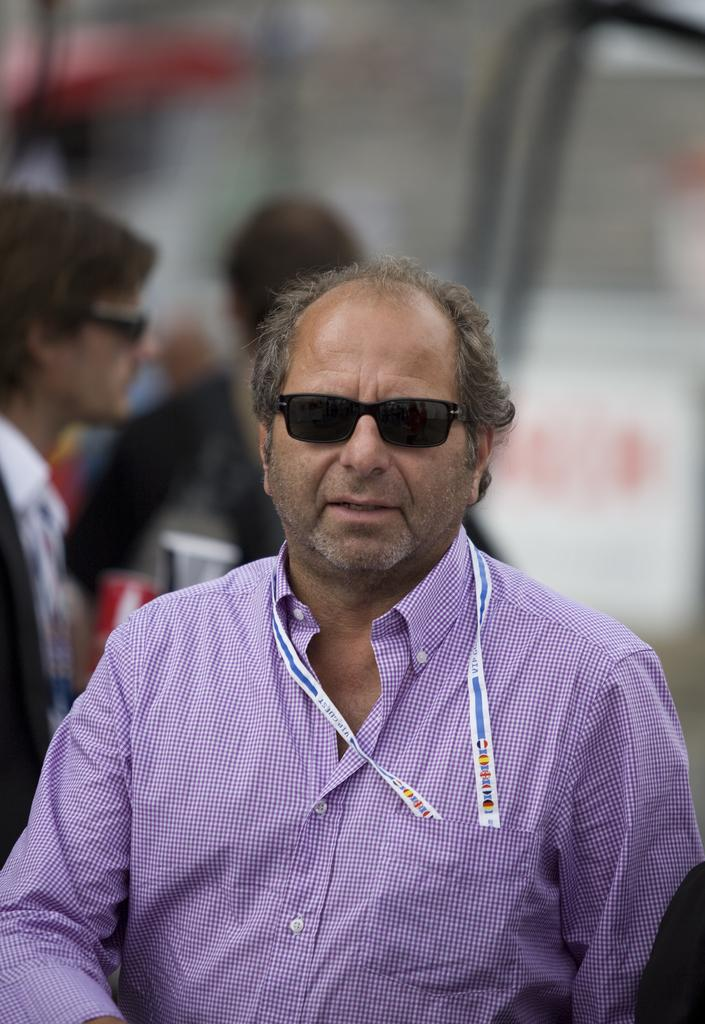Who is the main subject in the image? There is a man in the image. What is the man wearing on his upper body? The man is wearing a blue shirt. What type of eyewear is the man wearing? The man is wearing black shades. Can you describe the background of the image? There are many people in the background of the image, and the background is blurred. What type of quiver is the man carrying in the image? There is no quiver present in the image. What is the man's role as a servant in the image? There is no indication that the man is a servant in the image. 